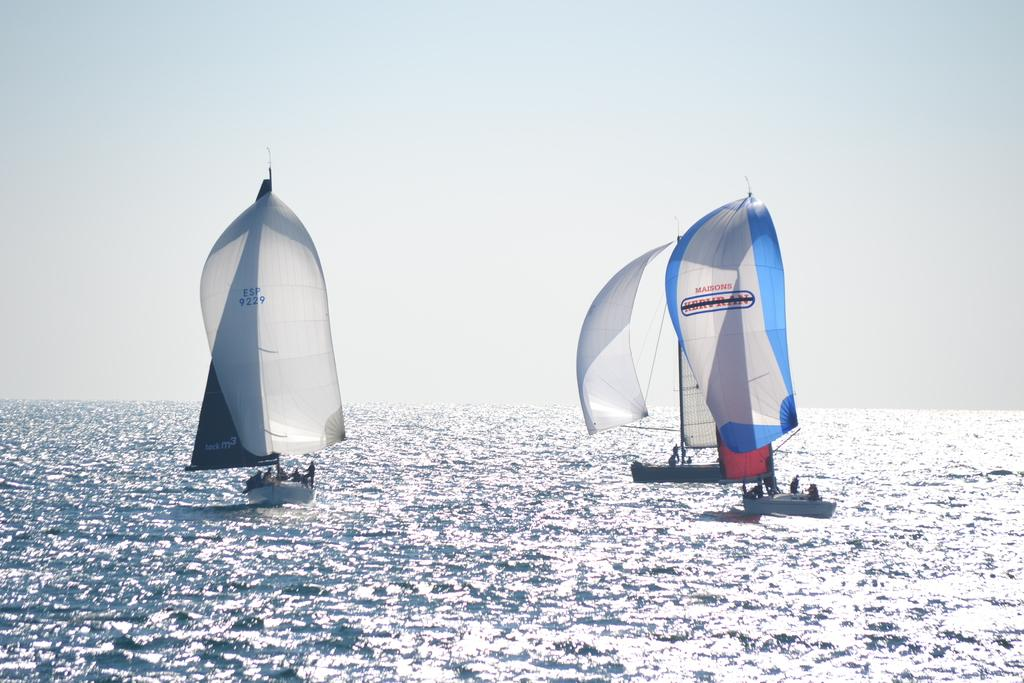What type of vehicles are in the image? There are boats in the image. Where are the boats located? The boats are on the water. What can be seen on the boats? There are groups of people on the boats. What is visible at the top of the image? The sky is visible at the top of the image. What is present at the bottom of the image? Water is present at the bottom of the image. Where is the cub's nest located in the image? There is no cub or nest present in the image. How does the steam affect the boats in the image? There is no steam present in the image; it only features boats on the water. 